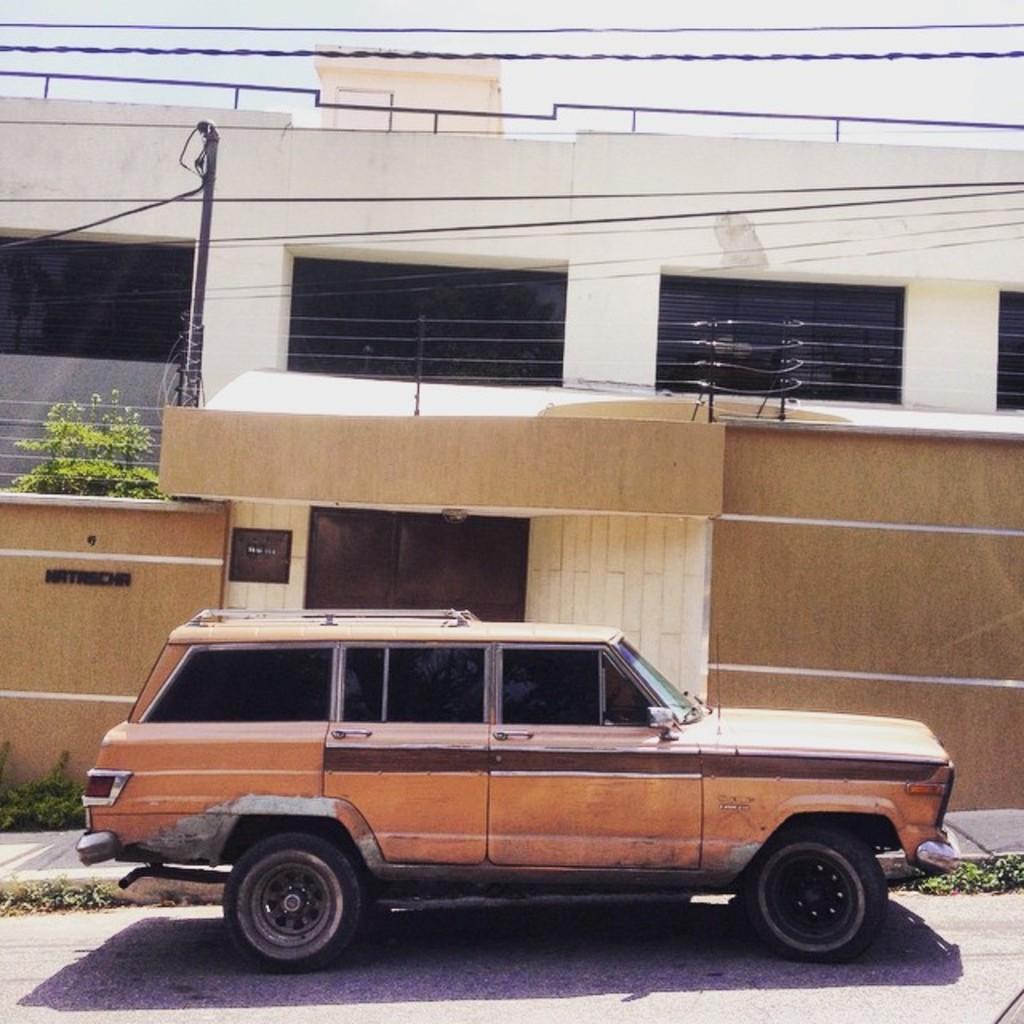Can you describe this image briefly? In the picture I can see a car which is in brown color is parked on the road and in the background, I can see a wall, wires, pole, trees and a house. 